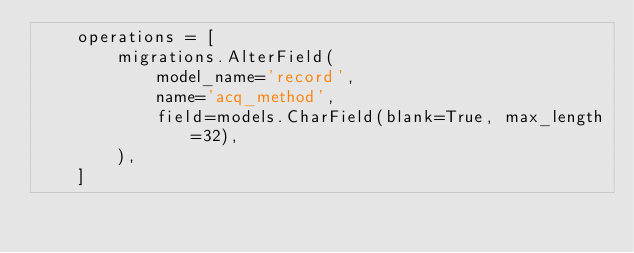<code> <loc_0><loc_0><loc_500><loc_500><_Python_>    operations = [
        migrations.AlterField(
            model_name='record',
            name='acq_method',
            field=models.CharField(blank=True, max_length=32),
        ),
    ]
</code> 